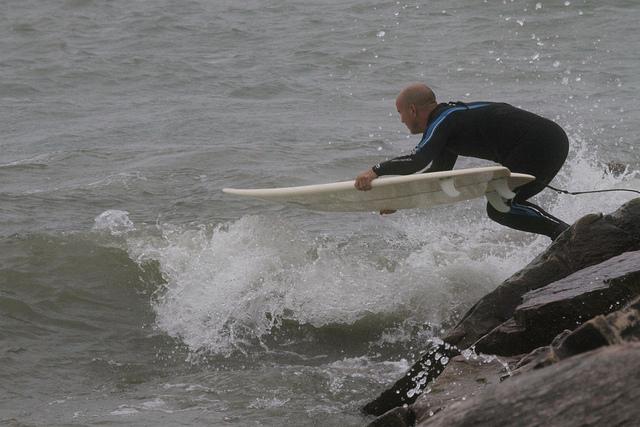Which way is the man moving?
Quick response, please. Left. Is the man overweight?
Be succinct. No. How old is this guy?
Answer briefly. 30. What is on the bottom of the surfboard?
Write a very short answer. Fins. Is he well positioned on the board?
Concise answer only. No. Does the surfer have long hair?
Quick response, please. No. What is written on the person's sleeve?
Keep it brief. Speedo. How is the water?
Write a very short answer. Cold. What does the person have in their hands?
Give a very brief answer. Surfboard. Is this a tropical location?
Keep it brief. No. 